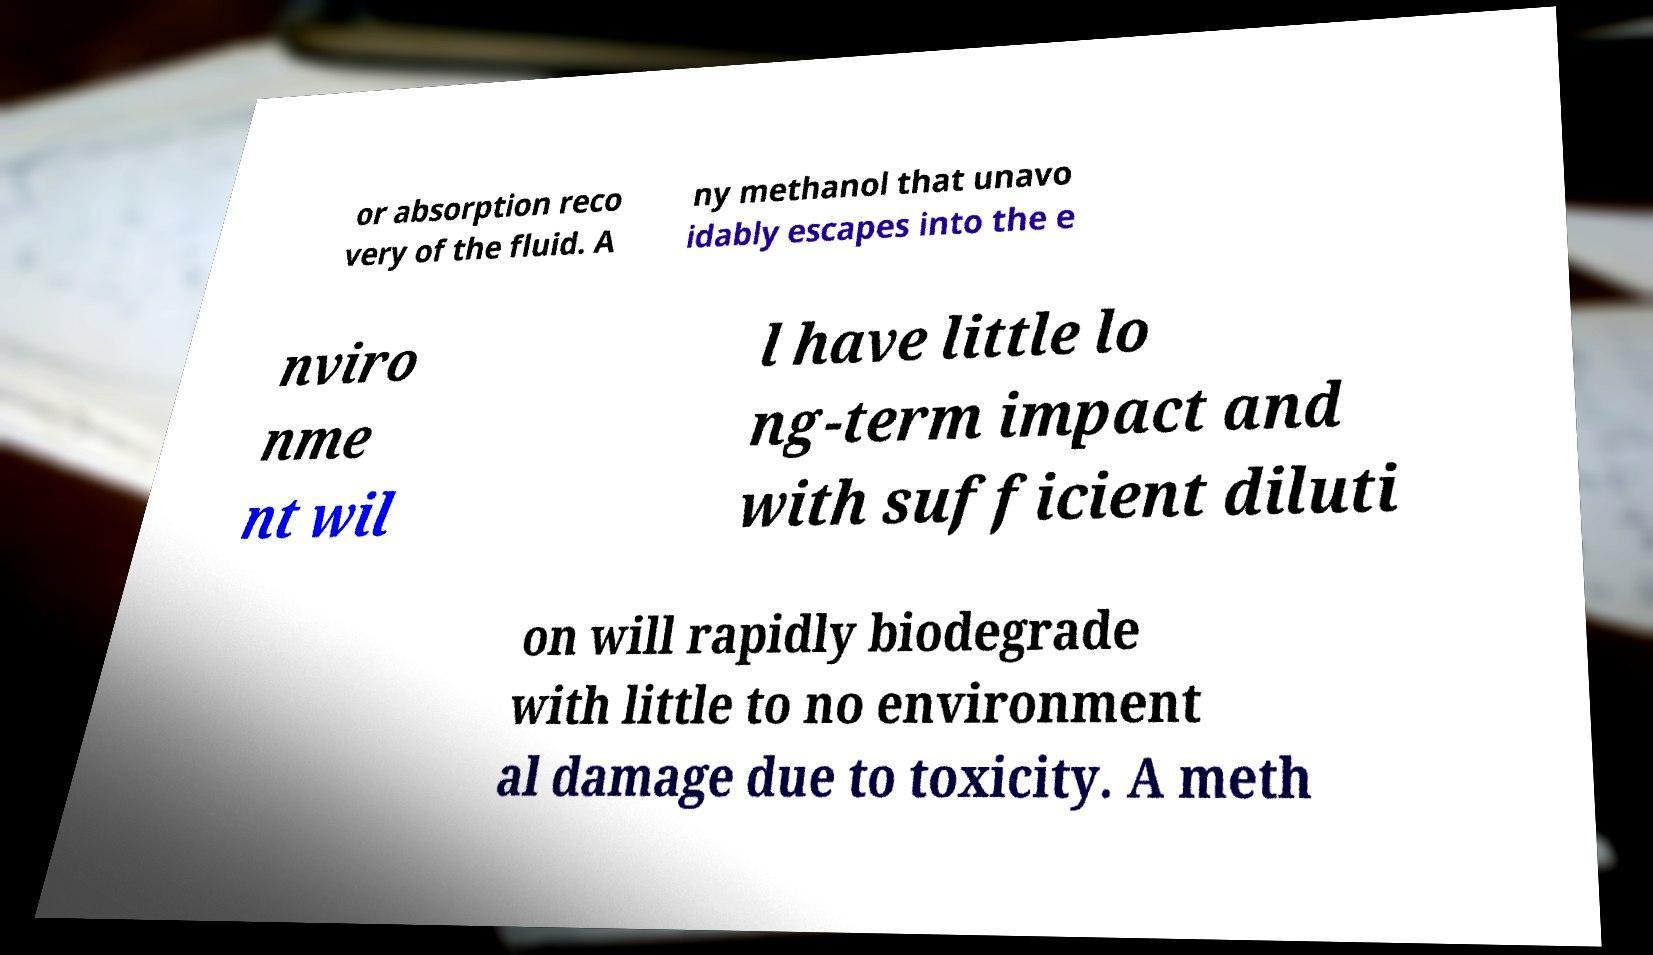There's text embedded in this image that I need extracted. Can you transcribe it verbatim? or absorption reco very of the fluid. A ny methanol that unavo idably escapes into the e nviro nme nt wil l have little lo ng-term impact and with sufficient diluti on will rapidly biodegrade with little to no environment al damage due to toxicity. A meth 